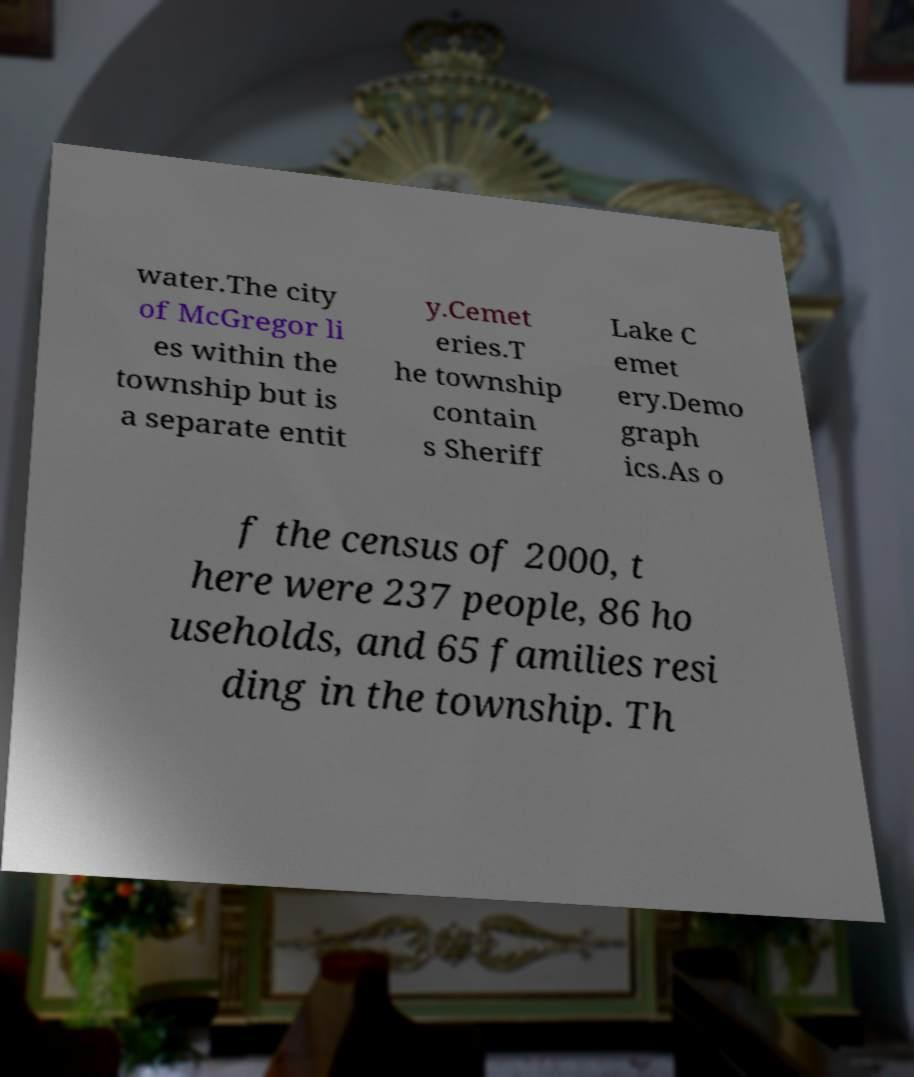There's text embedded in this image that I need extracted. Can you transcribe it verbatim? water.The city of McGregor li es within the township but is a separate entit y.Cemet eries.T he township contain s Sheriff Lake C emet ery.Demo graph ics.As o f the census of 2000, t here were 237 people, 86 ho useholds, and 65 families resi ding in the township. Th 